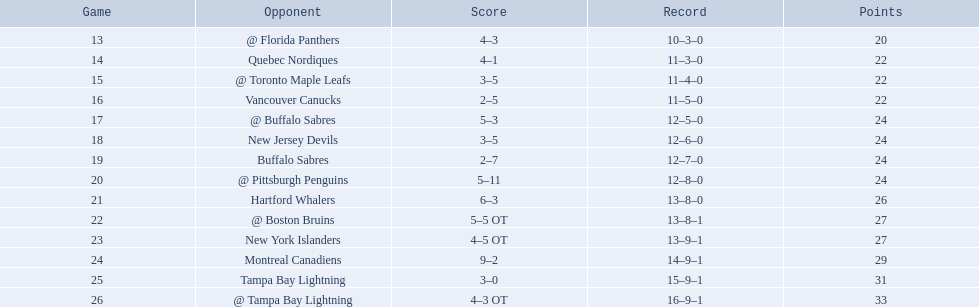Who are all of the teams? @ Florida Panthers, Quebec Nordiques, @ Toronto Maple Leafs, Vancouver Canucks, @ Buffalo Sabres, New Jersey Devils, Buffalo Sabres, @ Pittsburgh Penguins, Hartford Whalers, @ Boston Bruins, New York Islanders, Montreal Canadiens, Tampa Bay Lightning. What games finished in overtime? 22, 23, 26. In game number 23, who did they face? New York Islanders. 